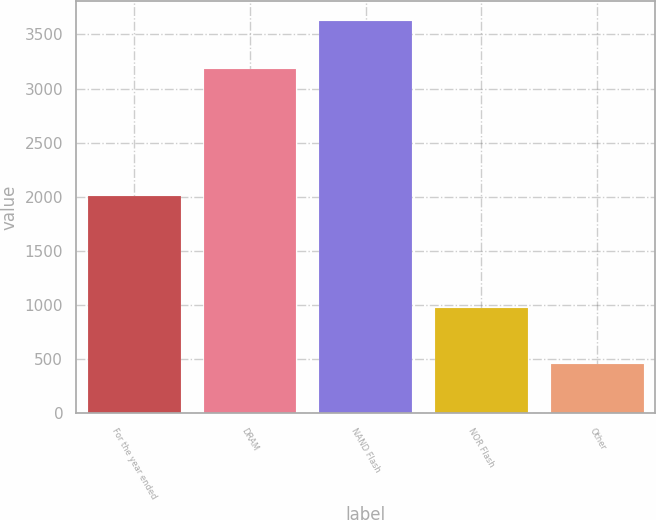Convert chart to OTSL. <chart><loc_0><loc_0><loc_500><loc_500><bar_chart><fcel>For the year ended<fcel>DRAM<fcel>NAND Flash<fcel>NOR Flash<fcel>Other<nl><fcel>2012<fcel>3178<fcel>3627<fcel>977<fcel>452<nl></chart> 